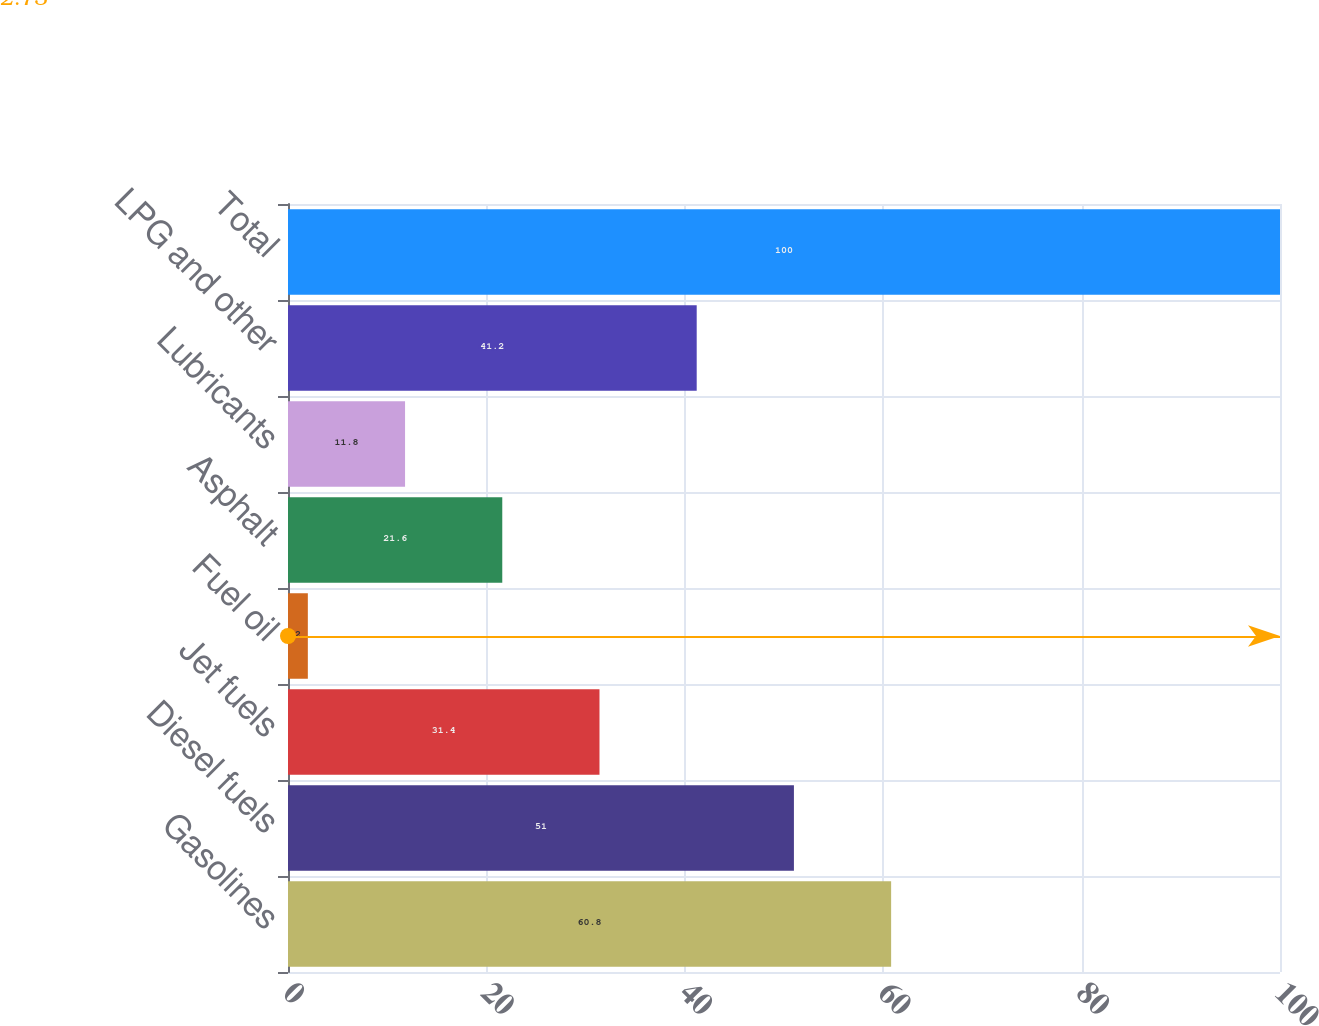<chart> <loc_0><loc_0><loc_500><loc_500><bar_chart><fcel>Gasolines<fcel>Diesel fuels<fcel>Jet fuels<fcel>Fuel oil<fcel>Asphalt<fcel>Lubricants<fcel>LPG and other<fcel>Total<nl><fcel>60.8<fcel>51<fcel>31.4<fcel>2<fcel>21.6<fcel>11.8<fcel>41.2<fcel>100<nl></chart> 